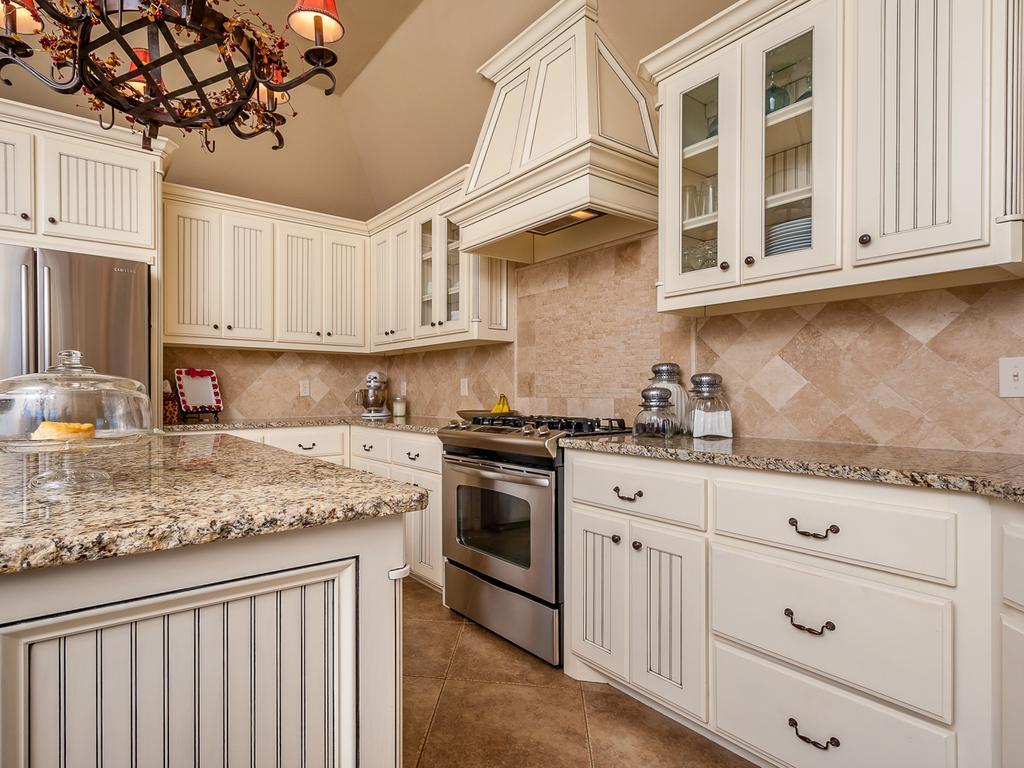How would you summarize this image in a sentence or two? This is an inside view of a kitchen. On the left side there is a table. On the right side, I can see the table cabinets on which a stove and few objects are placed and also there is a micro oven. At the top I can see the cupboards. On the left side there is a refrigerator. In the top left-hand corner there is a chandelier. 